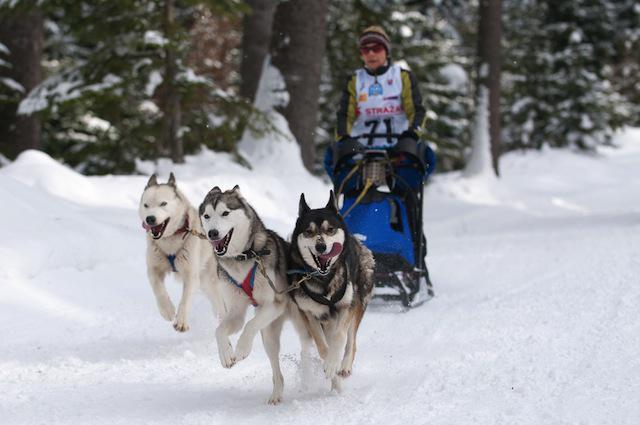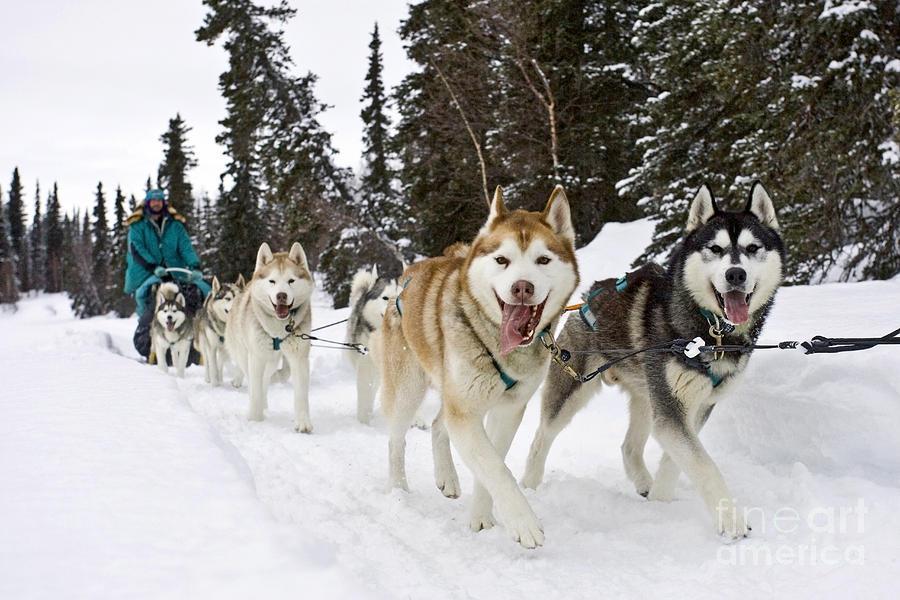The first image is the image on the left, the second image is the image on the right. For the images shown, is this caption "There are 3 sled dogs pulling a sled" true? Answer yes or no. Yes. The first image is the image on the left, the second image is the image on the right. Assess this claim about the two images: "In one image, three dogs pulling a sled are visible.". Correct or not? Answer yes or no. Yes. 